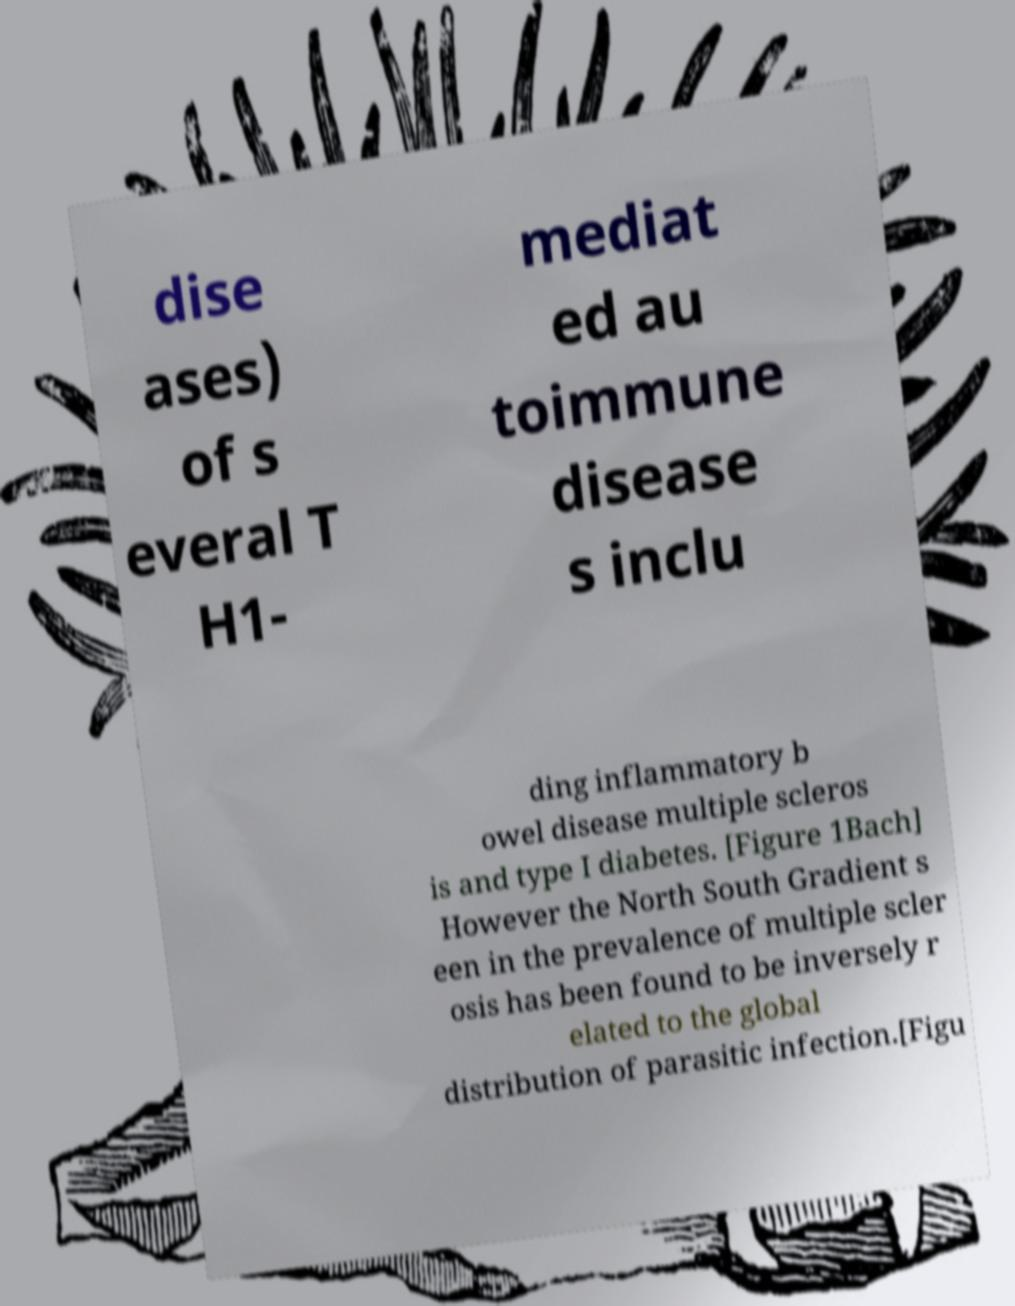Can you accurately transcribe the text from the provided image for me? dise ases) of s everal T H1- mediat ed au toimmune disease s inclu ding inflammatory b owel disease multiple scleros is and type I diabetes. [Figure 1Bach] However the North South Gradient s een in the prevalence of multiple scler osis has been found to be inversely r elated to the global distribution of parasitic infection.[Figu 